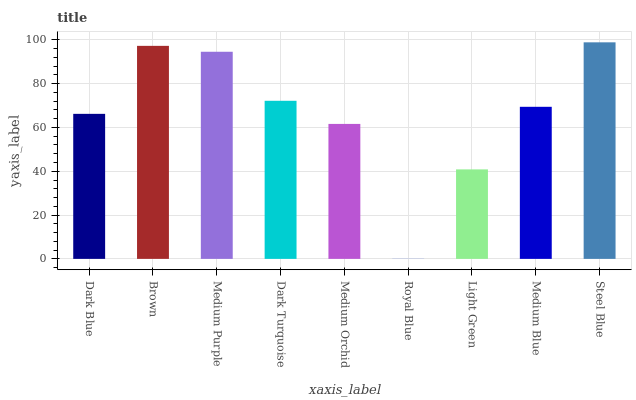Is Royal Blue the minimum?
Answer yes or no. Yes. Is Steel Blue the maximum?
Answer yes or no. Yes. Is Brown the minimum?
Answer yes or no. No. Is Brown the maximum?
Answer yes or no. No. Is Brown greater than Dark Blue?
Answer yes or no. Yes. Is Dark Blue less than Brown?
Answer yes or no. Yes. Is Dark Blue greater than Brown?
Answer yes or no. No. Is Brown less than Dark Blue?
Answer yes or no. No. Is Medium Blue the high median?
Answer yes or no. Yes. Is Medium Blue the low median?
Answer yes or no. Yes. Is Light Green the high median?
Answer yes or no. No. Is Dark Blue the low median?
Answer yes or no. No. 